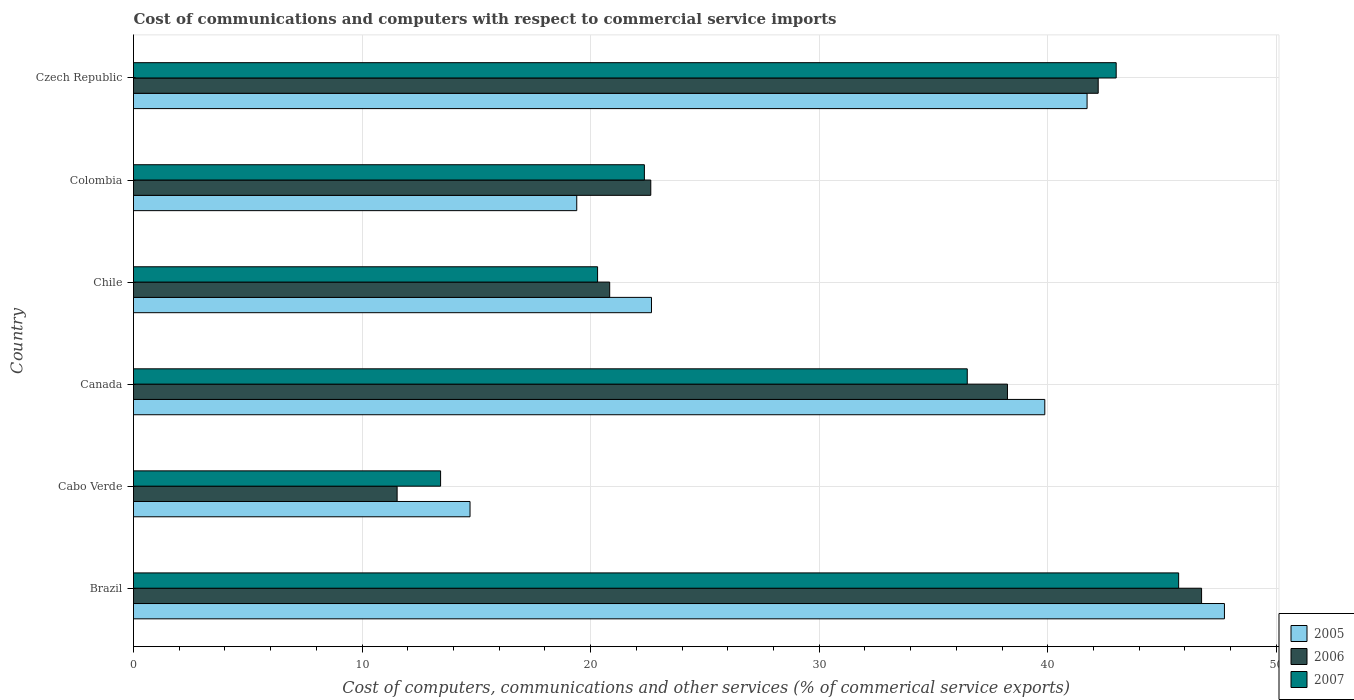How many groups of bars are there?
Ensure brevity in your answer.  6. Are the number of bars per tick equal to the number of legend labels?
Give a very brief answer. Yes. What is the label of the 1st group of bars from the top?
Provide a short and direct response. Czech Republic. In how many cases, is the number of bars for a given country not equal to the number of legend labels?
Provide a short and direct response. 0. What is the cost of communications and computers in 2007 in Brazil?
Offer a terse response. 45.72. Across all countries, what is the maximum cost of communications and computers in 2007?
Give a very brief answer. 45.72. Across all countries, what is the minimum cost of communications and computers in 2007?
Give a very brief answer. 13.44. In which country was the cost of communications and computers in 2005 minimum?
Make the answer very short. Cabo Verde. What is the total cost of communications and computers in 2005 in the graph?
Your answer should be compact. 186.09. What is the difference between the cost of communications and computers in 2007 in Cabo Verde and that in Czech Republic?
Your response must be concise. -29.56. What is the difference between the cost of communications and computers in 2006 in Cabo Verde and the cost of communications and computers in 2007 in Colombia?
Make the answer very short. -10.82. What is the average cost of communications and computers in 2007 per country?
Provide a succinct answer. 30.21. What is the difference between the cost of communications and computers in 2005 and cost of communications and computers in 2007 in Brazil?
Provide a succinct answer. 2. What is the ratio of the cost of communications and computers in 2007 in Cabo Verde to that in Chile?
Provide a succinct answer. 0.66. Is the cost of communications and computers in 2007 in Canada less than that in Colombia?
Your response must be concise. No. What is the difference between the highest and the second highest cost of communications and computers in 2006?
Your response must be concise. 4.52. What is the difference between the highest and the lowest cost of communications and computers in 2007?
Offer a very short reply. 32.29. In how many countries, is the cost of communications and computers in 2007 greater than the average cost of communications and computers in 2007 taken over all countries?
Ensure brevity in your answer.  3. What does the 2nd bar from the top in Czech Republic represents?
Ensure brevity in your answer.  2006. Is it the case that in every country, the sum of the cost of communications and computers in 2006 and cost of communications and computers in 2007 is greater than the cost of communications and computers in 2005?
Your answer should be very brief. Yes. Are the values on the major ticks of X-axis written in scientific E-notation?
Provide a succinct answer. No. How many legend labels are there?
Provide a short and direct response. 3. How are the legend labels stacked?
Your response must be concise. Vertical. What is the title of the graph?
Keep it short and to the point. Cost of communications and computers with respect to commercial service imports. Does "1963" appear as one of the legend labels in the graph?
Keep it short and to the point. No. What is the label or title of the X-axis?
Provide a succinct answer. Cost of computers, communications and other services (% of commerical service exports). What is the Cost of computers, communications and other services (% of commerical service exports) of 2005 in Brazil?
Your response must be concise. 47.73. What is the Cost of computers, communications and other services (% of commerical service exports) in 2006 in Brazil?
Your answer should be compact. 46.73. What is the Cost of computers, communications and other services (% of commerical service exports) in 2007 in Brazil?
Keep it short and to the point. 45.72. What is the Cost of computers, communications and other services (% of commerical service exports) of 2005 in Cabo Verde?
Ensure brevity in your answer.  14.72. What is the Cost of computers, communications and other services (% of commerical service exports) of 2006 in Cabo Verde?
Provide a short and direct response. 11.53. What is the Cost of computers, communications and other services (% of commerical service exports) in 2007 in Cabo Verde?
Offer a terse response. 13.44. What is the Cost of computers, communications and other services (% of commerical service exports) in 2005 in Canada?
Offer a terse response. 39.87. What is the Cost of computers, communications and other services (% of commerical service exports) in 2006 in Canada?
Your response must be concise. 38.24. What is the Cost of computers, communications and other services (% of commerical service exports) in 2007 in Canada?
Your answer should be very brief. 36.48. What is the Cost of computers, communications and other services (% of commerical service exports) in 2005 in Chile?
Make the answer very short. 22.66. What is the Cost of computers, communications and other services (% of commerical service exports) of 2006 in Chile?
Make the answer very short. 20.83. What is the Cost of computers, communications and other services (% of commerical service exports) in 2007 in Chile?
Offer a terse response. 20.3. What is the Cost of computers, communications and other services (% of commerical service exports) of 2005 in Colombia?
Provide a short and direct response. 19.39. What is the Cost of computers, communications and other services (% of commerical service exports) of 2006 in Colombia?
Offer a terse response. 22.63. What is the Cost of computers, communications and other services (% of commerical service exports) in 2007 in Colombia?
Give a very brief answer. 22.35. What is the Cost of computers, communications and other services (% of commerical service exports) of 2005 in Czech Republic?
Offer a terse response. 41.72. What is the Cost of computers, communications and other services (% of commerical service exports) in 2006 in Czech Republic?
Your answer should be compact. 42.2. What is the Cost of computers, communications and other services (% of commerical service exports) of 2007 in Czech Republic?
Provide a succinct answer. 42.99. Across all countries, what is the maximum Cost of computers, communications and other services (% of commerical service exports) of 2005?
Give a very brief answer. 47.73. Across all countries, what is the maximum Cost of computers, communications and other services (% of commerical service exports) of 2006?
Provide a short and direct response. 46.73. Across all countries, what is the maximum Cost of computers, communications and other services (% of commerical service exports) in 2007?
Your answer should be very brief. 45.72. Across all countries, what is the minimum Cost of computers, communications and other services (% of commerical service exports) in 2005?
Offer a terse response. 14.72. Across all countries, what is the minimum Cost of computers, communications and other services (% of commerical service exports) in 2006?
Provide a short and direct response. 11.53. Across all countries, what is the minimum Cost of computers, communications and other services (% of commerical service exports) of 2007?
Offer a very short reply. 13.44. What is the total Cost of computers, communications and other services (% of commerical service exports) of 2005 in the graph?
Offer a terse response. 186.09. What is the total Cost of computers, communications and other services (% of commerical service exports) in 2006 in the graph?
Give a very brief answer. 182.16. What is the total Cost of computers, communications and other services (% of commerical service exports) in 2007 in the graph?
Make the answer very short. 181.28. What is the difference between the Cost of computers, communications and other services (% of commerical service exports) in 2005 in Brazil and that in Cabo Verde?
Ensure brevity in your answer.  33.01. What is the difference between the Cost of computers, communications and other services (% of commerical service exports) of 2006 in Brazil and that in Cabo Verde?
Offer a very short reply. 35.19. What is the difference between the Cost of computers, communications and other services (% of commerical service exports) in 2007 in Brazil and that in Cabo Verde?
Offer a very short reply. 32.29. What is the difference between the Cost of computers, communications and other services (% of commerical service exports) of 2005 in Brazil and that in Canada?
Make the answer very short. 7.86. What is the difference between the Cost of computers, communications and other services (% of commerical service exports) of 2006 in Brazil and that in Canada?
Ensure brevity in your answer.  8.49. What is the difference between the Cost of computers, communications and other services (% of commerical service exports) of 2007 in Brazil and that in Canada?
Offer a terse response. 9.25. What is the difference between the Cost of computers, communications and other services (% of commerical service exports) in 2005 in Brazil and that in Chile?
Your answer should be very brief. 25.07. What is the difference between the Cost of computers, communications and other services (% of commerical service exports) of 2006 in Brazil and that in Chile?
Give a very brief answer. 25.89. What is the difference between the Cost of computers, communications and other services (% of commerical service exports) of 2007 in Brazil and that in Chile?
Keep it short and to the point. 25.42. What is the difference between the Cost of computers, communications and other services (% of commerical service exports) in 2005 in Brazil and that in Colombia?
Your answer should be very brief. 28.34. What is the difference between the Cost of computers, communications and other services (% of commerical service exports) of 2006 in Brazil and that in Colombia?
Ensure brevity in your answer.  24.1. What is the difference between the Cost of computers, communications and other services (% of commerical service exports) of 2007 in Brazil and that in Colombia?
Keep it short and to the point. 23.37. What is the difference between the Cost of computers, communications and other services (% of commerical service exports) in 2005 in Brazil and that in Czech Republic?
Your answer should be compact. 6.01. What is the difference between the Cost of computers, communications and other services (% of commerical service exports) of 2006 in Brazil and that in Czech Republic?
Keep it short and to the point. 4.52. What is the difference between the Cost of computers, communications and other services (% of commerical service exports) in 2007 in Brazil and that in Czech Republic?
Make the answer very short. 2.73. What is the difference between the Cost of computers, communications and other services (% of commerical service exports) in 2005 in Cabo Verde and that in Canada?
Ensure brevity in your answer.  -25.15. What is the difference between the Cost of computers, communications and other services (% of commerical service exports) in 2006 in Cabo Verde and that in Canada?
Offer a terse response. -26.7. What is the difference between the Cost of computers, communications and other services (% of commerical service exports) of 2007 in Cabo Verde and that in Canada?
Provide a succinct answer. -23.04. What is the difference between the Cost of computers, communications and other services (% of commerical service exports) in 2005 in Cabo Verde and that in Chile?
Your answer should be compact. -7.94. What is the difference between the Cost of computers, communications and other services (% of commerical service exports) in 2006 in Cabo Verde and that in Chile?
Your answer should be compact. -9.3. What is the difference between the Cost of computers, communications and other services (% of commerical service exports) in 2007 in Cabo Verde and that in Chile?
Offer a very short reply. -6.87. What is the difference between the Cost of computers, communications and other services (% of commerical service exports) of 2005 in Cabo Verde and that in Colombia?
Keep it short and to the point. -4.67. What is the difference between the Cost of computers, communications and other services (% of commerical service exports) of 2006 in Cabo Verde and that in Colombia?
Keep it short and to the point. -11.1. What is the difference between the Cost of computers, communications and other services (% of commerical service exports) in 2007 in Cabo Verde and that in Colombia?
Make the answer very short. -8.92. What is the difference between the Cost of computers, communications and other services (% of commerical service exports) in 2005 in Cabo Verde and that in Czech Republic?
Ensure brevity in your answer.  -27. What is the difference between the Cost of computers, communications and other services (% of commerical service exports) of 2006 in Cabo Verde and that in Czech Republic?
Your answer should be compact. -30.67. What is the difference between the Cost of computers, communications and other services (% of commerical service exports) in 2007 in Cabo Verde and that in Czech Republic?
Your response must be concise. -29.56. What is the difference between the Cost of computers, communications and other services (% of commerical service exports) in 2005 in Canada and that in Chile?
Give a very brief answer. 17.21. What is the difference between the Cost of computers, communications and other services (% of commerical service exports) of 2006 in Canada and that in Chile?
Your response must be concise. 17.4. What is the difference between the Cost of computers, communications and other services (% of commerical service exports) of 2007 in Canada and that in Chile?
Provide a succinct answer. 16.17. What is the difference between the Cost of computers, communications and other services (% of commerical service exports) in 2005 in Canada and that in Colombia?
Ensure brevity in your answer.  20.48. What is the difference between the Cost of computers, communications and other services (% of commerical service exports) of 2006 in Canada and that in Colombia?
Offer a very short reply. 15.61. What is the difference between the Cost of computers, communications and other services (% of commerical service exports) in 2007 in Canada and that in Colombia?
Offer a very short reply. 14.13. What is the difference between the Cost of computers, communications and other services (% of commerical service exports) in 2005 in Canada and that in Czech Republic?
Offer a terse response. -1.85. What is the difference between the Cost of computers, communications and other services (% of commerical service exports) in 2006 in Canada and that in Czech Republic?
Keep it short and to the point. -3.97. What is the difference between the Cost of computers, communications and other services (% of commerical service exports) in 2007 in Canada and that in Czech Republic?
Give a very brief answer. -6.52. What is the difference between the Cost of computers, communications and other services (% of commerical service exports) of 2005 in Chile and that in Colombia?
Your answer should be compact. 3.27. What is the difference between the Cost of computers, communications and other services (% of commerical service exports) of 2006 in Chile and that in Colombia?
Your answer should be compact. -1.8. What is the difference between the Cost of computers, communications and other services (% of commerical service exports) of 2007 in Chile and that in Colombia?
Provide a succinct answer. -2.05. What is the difference between the Cost of computers, communications and other services (% of commerical service exports) of 2005 in Chile and that in Czech Republic?
Your answer should be compact. -19.06. What is the difference between the Cost of computers, communications and other services (% of commerical service exports) of 2006 in Chile and that in Czech Republic?
Your answer should be very brief. -21.37. What is the difference between the Cost of computers, communications and other services (% of commerical service exports) in 2007 in Chile and that in Czech Republic?
Make the answer very short. -22.69. What is the difference between the Cost of computers, communications and other services (% of commerical service exports) in 2005 in Colombia and that in Czech Republic?
Give a very brief answer. -22.33. What is the difference between the Cost of computers, communications and other services (% of commerical service exports) of 2006 in Colombia and that in Czech Republic?
Give a very brief answer. -19.57. What is the difference between the Cost of computers, communications and other services (% of commerical service exports) of 2007 in Colombia and that in Czech Republic?
Make the answer very short. -20.64. What is the difference between the Cost of computers, communications and other services (% of commerical service exports) of 2005 in Brazil and the Cost of computers, communications and other services (% of commerical service exports) of 2006 in Cabo Verde?
Offer a terse response. 36.2. What is the difference between the Cost of computers, communications and other services (% of commerical service exports) in 2005 in Brazil and the Cost of computers, communications and other services (% of commerical service exports) in 2007 in Cabo Verde?
Keep it short and to the point. 34.29. What is the difference between the Cost of computers, communications and other services (% of commerical service exports) of 2006 in Brazil and the Cost of computers, communications and other services (% of commerical service exports) of 2007 in Cabo Verde?
Provide a short and direct response. 33.29. What is the difference between the Cost of computers, communications and other services (% of commerical service exports) in 2005 in Brazil and the Cost of computers, communications and other services (% of commerical service exports) in 2006 in Canada?
Offer a terse response. 9.49. What is the difference between the Cost of computers, communications and other services (% of commerical service exports) in 2005 in Brazil and the Cost of computers, communications and other services (% of commerical service exports) in 2007 in Canada?
Make the answer very short. 11.25. What is the difference between the Cost of computers, communications and other services (% of commerical service exports) of 2006 in Brazil and the Cost of computers, communications and other services (% of commerical service exports) of 2007 in Canada?
Provide a succinct answer. 10.25. What is the difference between the Cost of computers, communications and other services (% of commerical service exports) in 2005 in Brazil and the Cost of computers, communications and other services (% of commerical service exports) in 2006 in Chile?
Keep it short and to the point. 26.89. What is the difference between the Cost of computers, communications and other services (% of commerical service exports) in 2005 in Brazil and the Cost of computers, communications and other services (% of commerical service exports) in 2007 in Chile?
Offer a very short reply. 27.43. What is the difference between the Cost of computers, communications and other services (% of commerical service exports) of 2006 in Brazil and the Cost of computers, communications and other services (% of commerical service exports) of 2007 in Chile?
Your answer should be very brief. 26.42. What is the difference between the Cost of computers, communications and other services (% of commerical service exports) in 2005 in Brazil and the Cost of computers, communications and other services (% of commerical service exports) in 2006 in Colombia?
Your answer should be compact. 25.1. What is the difference between the Cost of computers, communications and other services (% of commerical service exports) of 2005 in Brazil and the Cost of computers, communications and other services (% of commerical service exports) of 2007 in Colombia?
Make the answer very short. 25.38. What is the difference between the Cost of computers, communications and other services (% of commerical service exports) of 2006 in Brazil and the Cost of computers, communications and other services (% of commerical service exports) of 2007 in Colombia?
Make the answer very short. 24.38. What is the difference between the Cost of computers, communications and other services (% of commerical service exports) of 2005 in Brazil and the Cost of computers, communications and other services (% of commerical service exports) of 2006 in Czech Republic?
Ensure brevity in your answer.  5.52. What is the difference between the Cost of computers, communications and other services (% of commerical service exports) of 2005 in Brazil and the Cost of computers, communications and other services (% of commerical service exports) of 2007 in Czech Republic?
Your answer should be very brief. 4.74. What is the difference between the Cost of computers, communications and other services (% of commerical service exports) of 2006 in Brazil and the Cost of computers, communications and other services (% of commerical service exports) of 2007 in Czech Republic?
Your answer should be very brief. 3.74. What is the difference between the Cost of computers, communications and other services (% of commerical service exports) of 2005 in Cabo Verde and the Cost of computers, communications and other services (% of commerical service exports) of 2006 in Canada?
Make the answer very short. -23.51. What is the difference between the Cost of computers, communications and other services (% of commerical service exports) of 2005 in Cabo Verde and the Cost of computers, communications and other services (% of commerical service exports) of 2007 in Canada?
Your answer should be very brief. -21.75. What is the difference between the Cost of computers, communications and other services (% of commerical service exports) in 2006 in Cabo Verde and the Cost of computers, communications and other services (% of commerical service exports) in 2007 in Canada?
Your answer should be very brief. -24.94. What is the difference between the Cost of computers, communications and other services (% of commerical service exports) in 2005 in Cabo Verde and the Cost of computers, communications and other services (% of commerical service exports) in 2006 in Chile?
Give a very brief answer. -6.11. What is the difference between the Cost of computers, communications and other services (% of commerical service exports) in 2005 in Cabo Verde and the Cost of computers, communications and other services (% of commerical service exports) in 2007 in Chile?
Your answer should be very brief. -5.58. What is the difference between the Cost of computers, communications and other services (% of commerical service exports) of 2006 in Cabo Verde and the Cost of computers, communications and other services (% of commerical service exports) of 2007 in Chile?
Provide a succinct answer. -8.77. What is the difference between the Cost of computers, communications and other services (% of commerical service exports) of 2005 in Cabo Verde and the Cost of computers, communications and other services (% of commerical service exports) of 2006 in Colombia?
Provide a short and direct response. -7.91. What is the difference between the Cost of computers, communications and other services (% of commerical service exports) of 2005 in Cabo Verde and the Cost of computers, communications and other services (% of commerical service exports) of 2007 in Colombia?
Your answer should be very brief. -7.63. What is the difference between the Cost of computers, communications and other services (% of commerical service exports) in 2006 in Cabo Verde and the Cost of computers, communications and other services (% of commerical service exports) in 2007 in Colombia?
Your response must be concise. -10.82. What is the difference between the Cost of computers, communications and other services (% of commerical service exports) of 2005 in Cabo Verde and the Cost of computers, communications and other services (% of commerical service exports) of 2006 in Czech Republic?
Give a very brief answer. -27.48. What is the difference between the Cost of computers, communications and other services (% of commerical service exports) of 2005 in Cabo Verde and the Cost of computers, communications and other services (% of commerical service exports) of 2007 in Czech Republic?
Offer a very short reply. -28.27. What is the difference between the Cost of computers, communications and other services (% of commerical service exports) of 2006 in Cabo Verde and the Cost of computers, communications and other services (% of commerical service exports) of 2007 in Czech Republic?
Offer a terse response. -31.46. What is the difference between the Cost of computers, communications and other services (% of commerical service exports) of 2005 in Canada and the Cost of computers, communications and other services (% of commerical service exports) of 2006 in Chile?
Make the answer very short. 19.04. What is the difference between the Cost of computers, communications and other services (% of commerical service exports) of 2005 in Canada and the Cost of computers, communications and other services (% of commerical service exports) of 2007 in Chile?
Offer a very short reply. 19.57. What is the difference between the Cost of computers, communications and other services (% of commerical service exports) of 2006 in Canada and the Cost of computers, communications and other services (% of commerical service exports) of 2007 in Chile?
Ensure brevity in your answer.  17.93. What is the difference between the Cost of computers, communications and other services (% of commerical service exports) in 2005 in Canada and the Cost of computers, communications and other services (% of commerical service exports) in 2006 in Colombia?
Your answer should be compact. 17.24. What is the difference between the Cost of computers, communications and other services (% of commerical service exports) of 2005 in Canada and the Cost of computers, communications and other services (% of commerical service exports) of 2007 in Colombia?
Provide a short and direct response. 17.52. What is the difference between the Cost of computers, communications and other services (% of commerical service exports) in 2006 in Canada and the Cost of computers, communications and other services (% of commerical service exports) in 2007 in Colombia?
Give a very brief answer. 15.88. What is the difference between the Cost of computers, communications and other services (% of commerical service exports) of 2005 in Canada and the Cost of computers, communications and other services (% of commerical service exports) of 2006 in Czech Republic?
Keep it short and to the point. -2.34. What is the difference between the Cost of computers, communications and other services (% of commerical service exports) in 2005 in Canada and the Cost of computers, communications and other services (% of commerical service exports) in 2007 in Czech Republic?
Make the answer very short. -3.12. What is the difference between the Cost of computers, communications and other services (% of commerical service exports) of 2006 in Canada and the Cost of computers, communications and other services (% of commerical service exports) of 2007 in Czech Republic?
Keep it short and to the point. -4.76. What is the difference between the Cost of computers, communications and other services (% of commerical service exports) of 2005 in Chile and the Cost of computers, communications and other services (% of commerical service exports) of 2006 in Colombia?
Ensure brevity in your answer.  0.03. What is the difference between the Cost of computers, communications and other services (% of commerical service exports) of 2005 in Chile and the Cost of computers, communications and other services (% of commerical service exports) of 2007 in Colombia?
Offer a very short reply. 0.31. What is the difference between the Cost of computers, communications and other services (% of commerical service exports) of 2006 in Chile and the Cost of computers, communications and other services (% of commerical service exports) of 2007 in Colombia?
Your answer should be very brief. -1.52. What is the difference between the Cost of computers, communications and other services (% of commerical service exports) of 2005 in Chile and the Cost of computers, communications and other services (% of commerical service exports) of 2006 in Czech Republic?
Give a very brief answer. -19.54. What is the difference between the Cost of computers, communications and other services (% of commerical service exports) of 2005 in Chile and the Cost of computers, communications and other services (% of commerical service exports) of 2007 in Czech Republic?
Offer a very short reply. -20.33. What is the difference between the Cost of computers, communications and other services (% of commerical service exports) of 2006 in Chile and the Cost of computers, communications and other services (% of commerical service exports) of 2007 in Czech Republic?
Offer a very short reply. -22.16. What is the difference between the Cost of computers, communications and other services (% of commerical service exports) of 2005 in Colombia and the Cost of computers, communications and other services (% of commerical service exports) of 2006 in Czech Republic?
Your answer should be very brief. -22.81. What is the difference between the Cost of computers, communications and other services (% of commerical service exports) in 2005 in Colombia and the Cost of computers, communications and other services (% of commerical service exports) in 2007 in Czech Republic?
Offer a very short reply. -23.6. What is the difference between the Cost of computers, communications and other services (% of commerical service exports) of 2006 in Colombia and the Cost of computers, communications and other services (% of commerical service exports) of 2007 in Czech Republic?
Give a very brief answer. -20.36. What is the average Cost of computers, communications and other services (% of commerical service exports) of 2005 per country?
Your answer should be compact. 31.02. What is the average Cost of computers, communications and other services (% of commerical service exports) in 2006 per country?
Your answer should be compact. 30.36. What is the average Cost of computers, communications and other services (% of commerical service exports) in 2007 per country?
Ensure brevity in your answer.  30.21. What is the difference between the Cost of computers, communications and other services (% of commerical service exports) of 2005 and Cost of computers, communications and other services (% of commerical service exports) of 2007 in Brazil?
Your answer should be compact. 2. What is the difference between the Cost of computers, communications and other services (% of commerical service exports) in 2006 and Cost of computers, communications and other services (% of commerical service exports) in 2007 in Brazil?
Make the answer very short. 1. What is the difference between the Cost of computers, communications and other services (% of commerical service exports) in 2005 and Cost of computers, communications and other services (% of commerical service exports) in 2006 in Cabo Verde?
Give a very brief answer. 3.19. What is the difference between the Cost of computers, communications and other services (% of commerical service exports) in 2005 and Cost of computers, communications and other services (% of commerical service exports) in 2007 in Cabo Verde?
Offer a very short reply. 1.29. What is the difference between the Cost of computers, communications and other services (% of commerical service exports) of 2006 and Cost of computers, communications and other services (% of commerical service exports) of 2007 in Cabo Verde?
Give a very brief answer. -1.9. What is the difference between the Cost of computers, communications and other services (% of commerical service exports) in 2005 and Cost of computers, communications and other services (% of commerical service exports) in 2006 in Canada?
Ensure brevity in your answer.  1.63. What is the difference between the Cost of computers, communications and other services (% of commerical service exports) in 2005 and Cost of computers, communications and other services (% of commerical service exports) in 2007 in Canada?
Your answer should be compact. 3.39. What is the difference between the Cost of computers, communications and other services (% of commerical service exports) in 2006 and Cost of computers, communications and other services (% of commerical service exports) in 2007 in Canada?
Your answer should be very brief. 1.76. What is the difference between the Cost of computers, communications and other services (% of commerical service exports) in 2005 and Cost of computers, communications and other services (% of commerical service exports) in 2006 in Chile?
Provide a succinct answer. 1.83. What is the difference between the Cost of computers, communications and other services (% of commerical service exports) in 2005 and Cost of computers, communications and other services (% of commerical service exports) in 2007 in Chile?
Offer a terse response. 2.36. What is the difference between the Cost of computers, communications and other services (% of commerical service exports) of 2006 and Cost of computers, communications and other services (% of commerical service exports) of 2007 in Chile?
Ensure brevity in your answer.  0.53. What is the difference between the Cost of computers, communications and other services (% of commerical service exports) of 2005 and Cost of computers, communications and other services (% of commerical service exports) of 2006 in Colombia?
Make the answer very short. -3.24. What is the difference between the Cost of computers, communications and other services (% of commerical service exports) in 2005 and Cost of computers, communications and other services (% of commerical service exports) in 2007 in Colombia?
Offer a very short reply. -2.96. What is the difference between the Cost of computers, communications and other services (% of commerical service exports) of 2006 and Cost of computers, communications and other services (% of commerical service exports) of 2007 in Colombia?
Provide a succinct answer. 0.28. What is the difference between the Cost of computers, communications and other services (% of commerical service exports) in 2005 and Cost of computers, communications and other services (% of commerical service exports) in 2006 in Czech Republic?
Your answer should be compact. -0.49. What is the difference between the Cost of computers, communications and other services (% of commerical service exports) in 2005 and Cost of computers, communications and other services (% of commerical service exports) in 2007 in Czech Republic?
Provide a succinct answer. -1.27. What is the difference between the Cost of computers, communications and other services (% of commerical service exports) in 2006 and Cost of computers, communications and other services (% of commerical service exports) in 2007 in Czech Republic?
Your response must be concise. -0.79. What is the ratio of the Cost of computers, communications and other services (% of commerical service exports) in 2005 in Brazil to that in Cabo Verde?
Offer a terse response. 3.24. What is the ratio of the Cost of computers, communications and other services (% of commerical service exports) in 2006 in Brazil to that in Cabo Verde?
Your response must be concise. 4.05. What is the ratio of the Cost of computers, communications and other services (% of commerical service exports) of 2007 in Brazil to that in Cabo Verde?
Your answer should be compact. 3.4. What is the ratio of the Cost of computers, communications and other services (% of commerical service exports) of 2005 in Brazil to that in Canada?
Provide a short and direct response. 1.2. What is the ratio of the Cost of computers, communications and other services (% of commerical service exports) in 2006 in Brazil to that in Canada?
Provide a short and direct response. 1.22. What is the ratio of the Cost of computers, communications and other services (% of commerical service exports) of 2007 in Brazil to that in Canada?
Provide a succinct answer. 1.25. What is the ratio of the Cost of computers, communications and other services (% of commerical service exports) in 2005 in Brazil to that in Chile?
Your answer should be compact. 2.11. What is the ratio of the Cost of computers, communications and other services (% of commerical service exports) in 2006 in Brazil to that in Chile?
Give a very brief answer. 2.24. What is the ratio of the Cost of computers, communications and other services (% of commerical service exports) of 2007 in Brazil to that in Chile?
Offer a terse response. 2.25. What is the ratio of the Cost of computers, communications and other services (% of commerical service exports) of 2005 in Brazil to that in Colombia?
Your answer should be compact. 2.46. What is the ratio of the Cost of computers, communications and other services (% of commerical service exports) in 2006 in Brazil to that in Colombia?
Provide a short and direct response. 2.06. What is the ratio of the Cost of computers, communications and other services (% of commerical service exports) in 2007 in Brazil to that in Colombia?
Offer a terse response. 2.05. What is the ratio of the Cost of computers, communications and other services (% of commerical service exports) of 2005 in Brazil to that in Czech Republic?
Offer a terse response. 1.14. What is the ratio of the Cost of computers, communications and other services (% of commerical service exports) in 2006 in Brazil to that in Czech Republic?
Provide a short and direct response. 1.11. What is the ratio of the Cost of computers, communications and other services (% of commerical service exports) of 2007 in Brazil to that in Czech Republic?
Make the answer very short. 1.06. What is the ratio of the Cost of computers, communications and other services (% of commerical service exports) of 2005 in Cabo Verde to that in Canada?
Your answer should be very brief. 0.37. What is the ratio of the Cost of computers, communications and other services (% of commerical service exports) in 2006 in Cabo Verde to that in Canada?
Provide a short and direct response. 0.3. What is the ratio of the Cost of computers, communications and other services (% of commerical service exports) in 2007 in Cabo Verde to that in Canada?
Your answer should be compact. 0.37. What is the ratio of the Cost of computers, communications and other services (% of commerical service exports) of 2005 in Cabo Verde to that in Chile?
Offer a terse response. 0.65. What is the ratio of the Cost of computers, communications and other services (% of commerical service exports) of 2006 in Cabo Verde to that in Chile?
Your response must be concise. 0.55. What is the ratio of the Cost of computers, communications and other services (% of commerical service exports) of 2007 in Cabo Verde to that in Chile?
Your answer should be very brief. 0.66. What is the ratio of the Cost of computers, communications and other services (% of commerical service exports) in 2005 in Cabo Verde to that in Colombia?
Provide a succinct answer. 0.76. What is the ratio of the Cost of computers, communications and other services (% of commerical service exports) of 2006 in Cabo Verde to that in Colombia?
Your response must be concise. 0.51. What is the ratio of the Cost of computers, communications and other services (% of commerical service exports) in 2007 in Cabo Verde to that in Colombia?
Offer a very short reply. 0.6. What is the ratio of the Cost of computers, communications and other services (% of commerical service exports) in 2005 in Cabo Verde to that in Czech Republic?
Give a very brief answer. 0.35. What is the ratio of the Cost of computers, communications and other services (% of commerical service exports) of 2006 in Cabo Verde to that in Czech Republic?
Keep it short and to the point. 0.27. What is the ratio of the Cost of computers, communications and other services (% of commerical service exports) in 2007 in Cabo Verde to that in Czech Republic?
Your response must be concise. 0.31. What is the ratio of the Cost of computers, communications and other services (% of commerical service exports) in 2005 in Canada to that in Chile?
Your answer should be compact. 1.76. What is the ratio of the Cost of computers, communications and other services (% of commerical service exports) of 2006 in Canada to that in Chile?
Your answer should be very brief. 1.84. What is the ratio of the Cost of computers, communications and other services (% of commerical service exports) in 2007 in Canada to that in Chile?
Your answer should be very brief. 1.8. What is the ratio of the Cost of computers, communications and other services (% of commerical service exports) in 2005 in Canada to that in Colombia?
Make the answer very short. 2.06. What is the ratio of the Cost of computers, communications and other services (% of commerical service exports) in 2006 in Canada to that in Colombia?
Give a very brief answer. 1.69. What is the ratio of the Cost of computers, communications and other services (% of commerical service exports) in 2007 in Canada to that in Colombia?
Your answer should be very brief. 1.63. What is the ratio of the Cost of computers, communications and other services (% of commerical service exports) in 2005 in Canada to that in Czech Republic?
Your answer should be very brief. 0.96. What is the ratio of the Cost of computers, communications and other services (% of commerical service exports) of 2006 in Canada to that in Czech Republic?
Make the answer very short. 0.91. What is the ratio of the Cost of computers, communications and other services (% of commerical service exports) in 2007 in Canada to that in Czech Republic?
Your response must be concise. 0.85. What is the ratio of the Cost of computers, communications and other services (% of commerical service exports) in 2005 in Chile to that in Colombia?
Give a very brief answer. 1.17. What is the ratio of the Cost of computers, communications and other services (% of commerical service exports) in 2006 in Chile to that in Colombia?
Your answer should be very brief. 0.92. What is the ratio of the Cost of computers, communications and other services (% of commerical service exports) in 2007 in Chile to that in Colombia?
Give a very brief answer. 0.91. What is the ratio of the Cost of computers, communications and other services (% of commerical service exports) in 2005 in Chile to that in Czech Republic?
Give a very brief answer. 0.54. What is the ratio of the Cost of computers, communications and other services (% of commerical service exports) in 2006 in Chile to that in Czech Republic?
Give a very brief answer. 0.49. What is the ratio of the Cost of computers, communications and other services (% of commerical service exports) of 2007 in Chile to that in Czech Republic?
Give a very brief answer. 0.47. What is the ratio of the Cost of computers, communications and other services (% of commerical service exports) of 2005 in Colombia to that in Czech Republic?
Provide a succinct answer. 0.46. What is the ratio of the Cost of computers, communications and other services (% of commerical service exports) in 2006 in Colombia to that in Czech Republic?
Offer a terse response. 0.54. What is the ratio of the Cost of computers, communications and other services (% of commerical service exports) in 2007 in Colombia to that in Czech Republic?
Offer a very short reply. 0.52. What is the difference between the highest and the second highest Cost of computers, communications and other services (% of commerical service exports) of 2005?
Make the answer very short. 6.01. What is the difference between the highest and the second highest Cost of computers, communications and other services (% of commerical service exports) in 2006?
Offer a very short reply. 4.52. What is the difference between the highest and the second highest Cost of computers, communications and other services (% of commerical service exports) of 2007?
Your response must be concise. 2.73. What is the difference between the highest and the lowest Cost of computers, communications and other services (% of commerical service exports) of 2005?
Give a very brief answer. 33.01. What is the difference between the highest and the lowest Cost of computers, communications and other services (% of commerical service exports) in 2006?
Make the answer very short. 35.19. What is the difference between the highest and the lowest Cost of computers, communications and other services (% of commerical service exports) in 2007?
Your response must be concise. 32.29. 